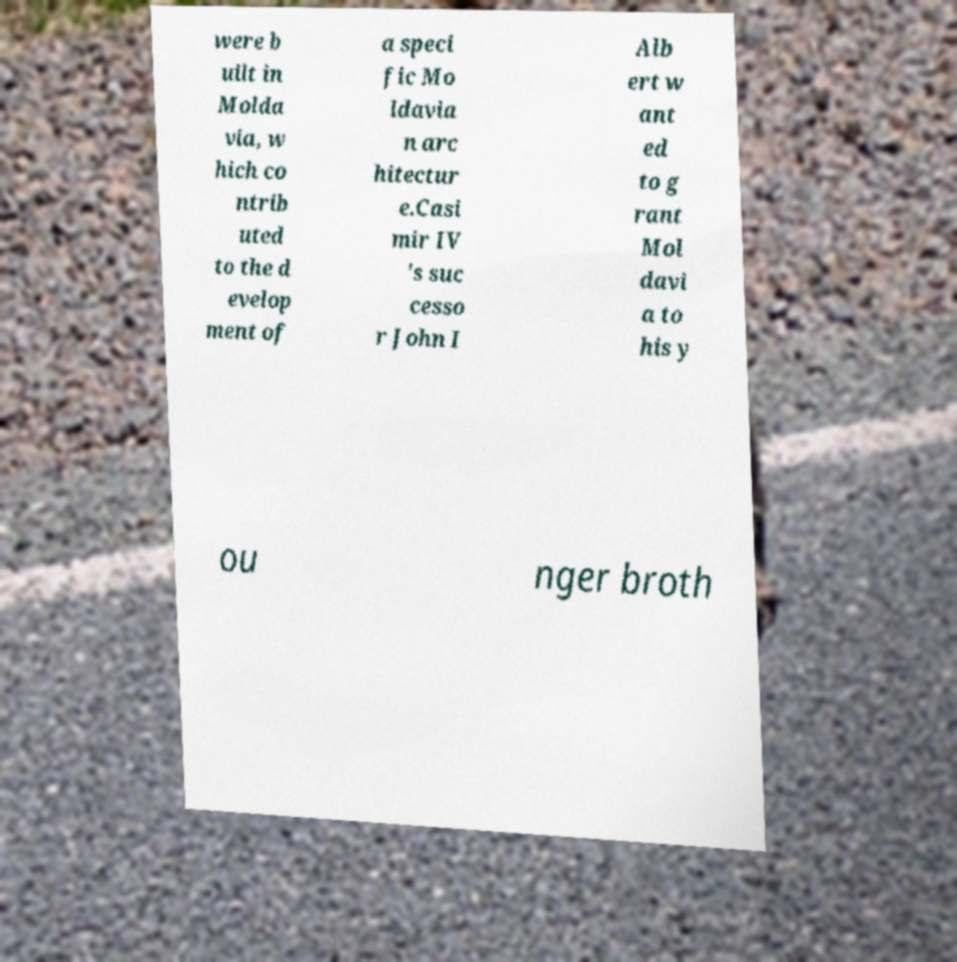I need the written content from this picture converted into text. Can you do that? were b uilt in Molda via, w hich co ntrib uted to the d evelop ment of a speci fic Mo ldavia n arc hitectur e.Casi mir IV 's suc cesso r John I Alb ert w ant ed to g rant Mol davi a to his y ou nger broth 